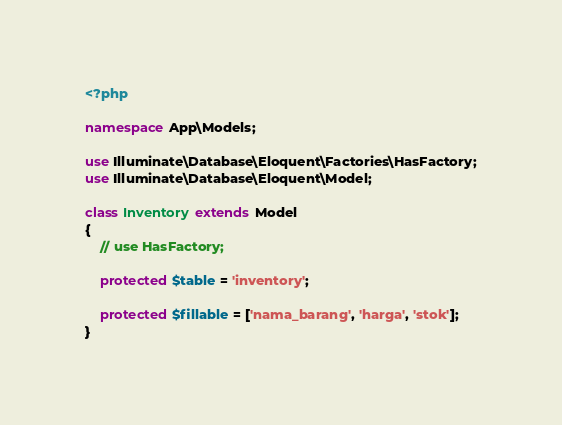Convert code to text. <code><loc_0><loc_0><loc_500><loc_500><_PHP_><?php

namespace App\Models;

use Illuminate\Database\Eloquent\Factories\HasFactory;
use Illuminate\Database\Eloquent\Model;

class Inventory extends Model
{
    // use HasFactory;

    protected $table = 'inventory';

    protected $fillable = ['nama_barang', 'harga', 'stok'];
}
</code> 